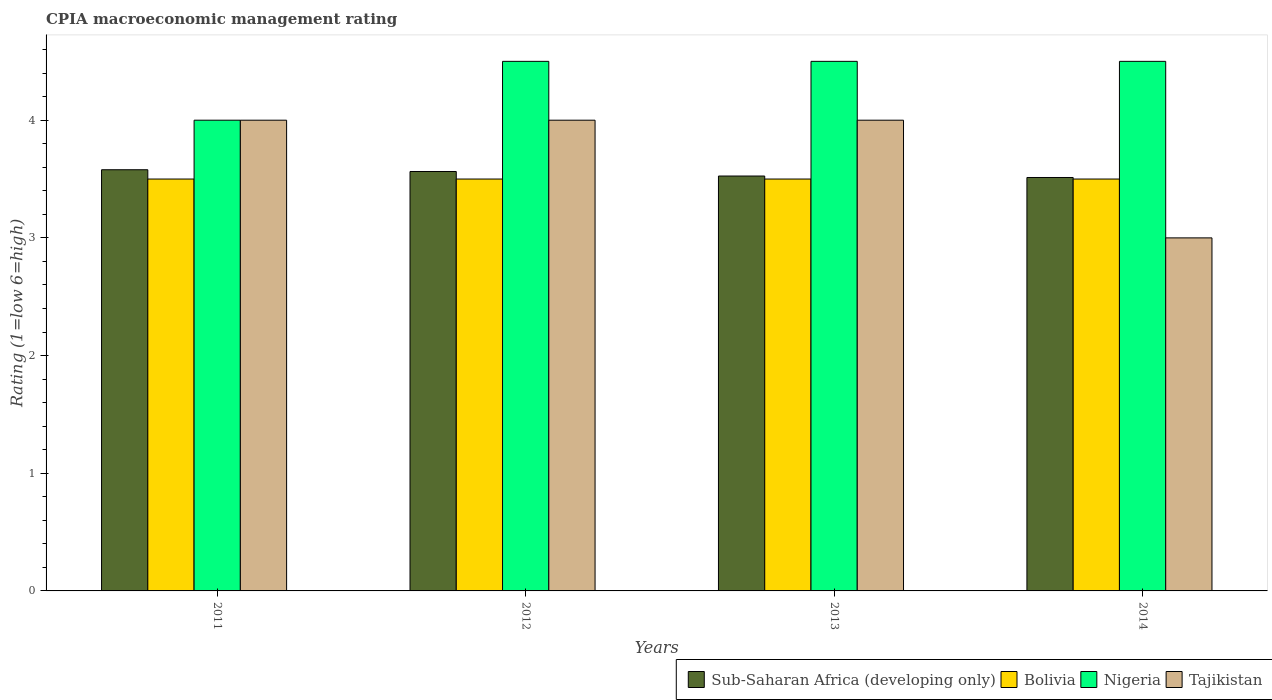How many groups of bars are there?
Your answer should be compact. 4. Are the number of bars per tick equal to the number of legend labels?
Your answer should be compact. Yes. What is the label of the 2nd group of bars from the left?
Offer a very short reply. 2012. In which year was the CPIA rating in Bolivia maximum?
Offer a very short reply. 2011. What is the total CPIA rating in Nigeria in the graph?
Your answer should be very brief. 17.5. What is the average CPIA rating in Sub-Saharan Africa (developing only) per year?
Provide a short and direct response. 3.55. What is the ratio of the CPIA rating in Tajikistan in 2013 to that in 2014?
Keep it short and to the point. 1.33. What is the difference between the highest and the second highest CPIA rating in Nigeria?
Offer a very short reply. 0. Is the sum of the CPIA rating in Sub-Saharan Africa (developing only) in 2012 and 2014 greater than the maximum CPIA rating in Bolivia across all years?
Give a very brief answer. Yes. Is it the case that in every year, the sum of the CPIA rating in Bolivia and CPIA rating in Nigeria is greater than the sum of CPIA rating in Sub-Saharan Africa (developing only) and CPIA rating in Tajikistan?
Provide a succinct answer. No. What does the 1st bar from the left in 2012 represents?
Provide a succinct answer. Sub-Saharan Africa (developing only). What does the 4th bar from the right in 2014 represents?
Your answer should be compact. Sub-Saharan Africa (developing only). Is it the case that in every year, the sum of the CPIA rating in Sub-Saharan Africa (developing only) and CPIA rating in Tajikistan is greater than the CPIA rating in Bolivia?
Offer a terse response. Yes. How many bars are there?
Provide a short and direct response. 16. What is the difference between two consecutive major ticks on the Y-axis?
Provide a short and direct response. 1. Are the values on the major ticks of Y-axis written in scientific E-notation?
Make the answer very short. No. Does the graph contain any zero values?
Your answer should be very brief. No. Does the graph contain grids?
Your answer should be very brief. No. Where does the legend appear in the graph?
Ensure brevity in your answer.  Bottom right. What is the title of the graph?
Ensure brevity in your answer.  CPIA macroeconomic management rating. Does "South Africa" appear as one of the legend labels in the graph?
Give a very brief answer. No. What is the Rating (1=low 6=high) in Sub-Saharan Africa (developing only) in 2011?
Ensure brevity in your answer.  3.58. What is the Rating (1=low 6=high) of Nigeria in 2011?
Offer a very short reply. 4. What is the Rating (1=low 6=high) in Sub-Saharan Africa (developing only) in 2012?
Keep it short and to the point. 3.56. What is the Rating (1=low 6=high) of Nigeria in 2012?
Keep it short and to the point. 4.5. What is the Rating (1=low 6=high) of Tajikistan in 2012?
Offer a very short reply. 4. What is the Rating (1=low 6=high) of Sub-Saharan Africa (developing only) in 2013?
Offer a terse response. 3.53. What is the Rating (1=low 6=high) in Bolivia in 2013?
Keep it short and to the point. 3.5. What is the Rating (1=low 6=high) in Sub-Saharan Africa (developing only) in 2014?
Make the answer very short. 3.51. What is the Rating (1=low 6=high) of Bolivia in 2014?
Provide a succinct answer. 3.5. What is the Rating (1=low 6=high) of Nigeria in 2014?
Ensure brevity in your answer.  4.5. What is the Rating (1=low 6=high) of Tajikistan in 2014?
Ensure brevity in your answer.  3. Across all years, what is the maximum Rating (1=low 6=high) in Sub-Saharan Africa (developing only)?
Give a very brief answer. 3.58. Across all years, what is the maximum Rating (1=low 6=high) of Bolivia?
Your answer should be very brief. 3.5. Across all years, what is the maximum Rating (1=low 6=high) of Nigeria?
Make the answer very short. 4.5. Across all years, what is the minimum Rating (1=low 6=high) of Sub-Saharan Africa (developing only)?
Keep it short and to the point. 3.51. Across all years, what is the minimum Rating (1=low 6=high) in Bolivia?
Your answer should be compact. 3.5. Across all years, what is the minimum Rating (1=low 6=high) of Nigeria?
Your answer should be very brief. 4. What is the total Rating (1=low 6=high) of Sub-Saharan Africa (developing only) in the graph?
Your answer should be compact. 14.18. What is the total Rating (1=low 6=high) of Bolivia in the graph?
Offer a terse response. 14. What is the total Rating (1=low 6=high) of Nigeria in the graph?
Your answer should be compact. 17.5. What is the total Rating (1=low 6=high) in Tajikistan in the graph?
Ensure brevity in your answer.  15. What is the difference between the Rating (1=low 6=high) in Sub-Saharan Africa (developing only) in 2011 and that in 2012?
Offer a very short reply. 0.01. What is the difference between the Rating (1=low 6=high) of Bolivia in 2011 and that in 2012?
Make the answer very short. 0. What is the difference between the Rating (1=low 6=high) of Tajikistan in 2011 and that in 2012?
Keep it short and to the point. 0. What is the difference between the Rating (1=low 6=high) of Sub-Saharan Africa (developing only) in 2011 and that in 2013?
Your answer should be compact. 0.05. What is the difference between the Rating (1=low 6=high) in Bolivia in 2011 and that in 2013?
Give a very brief answer. 0. What is the difference between the Rating (1=low 6=high) of Tajikistan in 2011 and that in 2013?
Offer a terse response. 0. What is the difference between the Rating (1=low 6=high) of Sub-Saharan Africa (developing only) in 2011 and that in 2014?
Provide a short and direct response. 0.07. What is the difference between the Rating (1=low 6=high) of Bolivia in 2011 and that in 2014?
Give a very brief answer. 0. What is the difference between the Rating (1=low 6=high) in Sub-Saharan Africa (developing only) in 2012 and that in 2013?
Keep it short and to the point. 0.04. What is the difference between the Rating (1=low 6=high) of Bolivia in 2012 and that in 2013?
Provide a succinct answer. 0. What is the difference between the Rating (1=low 6=high) of Nigeria in 2012 and that in 2013?
Your response must be concise. 0. What is the difference between the Rating (1=low 6=high) in Tajikistan in 2012 and that in 2013?
Your answer should be very brief. 0. What is the difference between the Rating (1=low 6=high) of Sub-Saharan Africa (developing only) in 2012 and that in 2014?
Offer a very short reply. 0.05. What is the difference between the Rating (1=low 6=high) of Bolivia in 2012 and that in 2014?
Provide a succinct answer. 0. What is the difference between the Rating (1=low 6=high) of Nigeria in 2012 and that in 2014?
Give a very brief answer. 0. What is the difference between the Rating (1=low 6=high) of Tajikistan in 2012 and that in 2014?
Ensure brevity in your answer.  1. What is the difference between the Rating (1=low 6=high) of Sub-Saharan Africa (developing only) in 2013 and that in 2014?
Your answer should be very brief. 0.01. What is the difference between the Rating (1=low 6=high) in Nigeria in 2013 and that in 2014?
Keep it short and to the point. 0. What is the difference between the Rating (1=low 6=high) of Sub-Saharan Africa (developing only) in 2011 and the Rating (1=low 6=high) of Bolivia in 2012?
Keep it short and to the point. 0.08. What is the difference between the Rating (1=low 6=high) of Sub-Saharan Africa (developing only) in 2011 and the Rating (1=low 6=high) of Nigeria in 2012?
Ensure brevity in your answer.  -0.92. What is the difference between the Rating (1=low 6=high) in Sub-Saharan Africa (developing only) in 2011 and the Rating (1=low 6=high) in Tajikistan in 2012?
Offer a very short reply. -0.42. What is the difference between the Rating (1=low 6=high) of Sub-Saharan Africa (developing only) in 2011 and the Rating (1=low 6=high) of Bolivia in 2013?
Make the answer very short. 0.08. What is the difference between the Rating (1=low 6=high) of Sub-Saharan Africa (developing only) in 2011 and the Rating (1=low 6=high) of Nigeria in 2013?
Your answer should be very brief. -0.92. What is the difference between the Rating (1=low 6=high) in Sub-Saharan Africa (developing only) in 2011 and the Rating (1=low 6=high) in Tajikistan in 2013?
Provide a succinct answer. -0.42. What is the difference between the Rating (1=low 6=high) in Bolivia in 2011 and the Rating (1=low 6=high) in Tajikistan in 2013?
Your answer should be compact. -0.5. What is the difference between the Rating (1=low 6=high) in Nigeria in 2011 and the Rating (1=low 6=high) in Tajikistan in 2013?
Your answer should be compact. 0. What is the difference between the Rating (1=low 6=high) in Sub-Saharan Africa (developing only) in 2011 and the Rating (1=low 6=high) in Bolivia in 2014?
Offer a terse response. 0.08. What is the difference between the Rating (1=low 6=high) of Sub-Saharan Africa (developing only) in 2011 and the Rating (1=low 6=high) of Nigeria in 2014?
Provide a succinct answer. -0.92. What is the difference between the Rating (1=low 6=high) in Sub-Saharan Africa (developing only) in 2011 and the Rating (1=low 6=high) in Tajikistan in 2014?
Offer a terse response. 0.58. What is the difference between the Rating (1=low 6=high) of Bolivia in 2011 and the Rating (1=low 6=high) of Tajikistan in 2014?
Your response must be concise. 0.5. What is the difference between the Rating (1=low 6=high) of Nigeria in 2011 and the Rating (1=low 6=high) of Tajikistan in 2014?
Your answer should be very brief. 1. What is the difference between the Rating (1=low 6=high) of Sub-Saharan Africa (developing only) in 2012 and the Rating (1=low 6=high) of Bolivia in 2013?
Give a very brief answer. 0.06. What is the difference between the Rating (1=low 6=high) of Sub-Saharan Africa (developing only) in 2012 and the Rating (1=low 6=high) of Nigeria in 2013?
Give a very brief answer. -0.94. What is the difference between the Rating (1=low 6=high) of Sub-Saharan Africa (developing only) in 2012 and the Rating (1=low 6=high) of Tajikistan in 2013?
Keep it short and to the point. -0.44. What is the difference between the Rating (1=low 6=high) in Nigeria in 2012 and the Rating (1=low 6=high) in Tajikistan in 2013?
Your answer should be compact. 0.5. What is the difference between the Rating (1=low 6=high) of Sub-Saharan Africa (developing only) in 2012 and the Rating (1=low 6=high) of Bolivia in 2014?
Your answer should be compact. 0.06. What is the difference between the Rating (1=low 6=high) of Sub-Saharan Africa (developing only) in 2012 and the Rating (1=low 6=high) of Nigeria in 2014?
Keep it short and to the point. -0.94. What is the difference between the Rating (1=low 6=high) in Sub-Saharan Africa (developing only) in 2012 and the Rating (1=low 6=high) in Tajikistan in 2014?
Provide a succinct answer. 0.56. What is the difference between the Rating (1=low 6=high) of Bolivia in 2012 and the Rating (1=low 6=high) of Tajikistan in 2014?
Make the answer very short. 0.5. What is the difference between the Rating (1=low 6=high) of Nigeria in 2012 and the Rating (1=low 6=high) of Tajikistan in 2014?
Your answer should be very brief. 1.5. What is the difference between the Rating (1=low 6=high) of Sub-Saharan Africa (developing only) in 2013 and the Rating (1=low 6=high) of Bolivia in 2014?
Provide a succinct answer. 0.03. What is the difference between the Rating (1=low 6=high) in Sub-Saharan Africa (developing only) in 2013 and the Rating (1=low 6=high) in Nigeria in 2014?
Provide a short and direct response. -0.97. What is the difference between the Rating (1=low 6=high) of Sub-Saharan Africa (developing only) in 2013 and the Rating (1=low 6=high) of Tajikistan in 2014?
Your response must be concise. 0.53. What is the difference between the Rating (1=low 6=high) in Nigeria in 2013 and the Rating (1=low 6=high) in Tajikistan in 2014?
Your answer should be very brief. 1.5. What is the average Rating (1=low 6=high) of Sub-Saharan Africa (developing only) per year?
Offer a terse response. 3.55. What is the average Rating (1=low 6=high) in Bolivia per year?
Your answer should be compact. 3.5. What is the average Rating (1=low 6=high) in Nigeria per year?
Make the answer very short. 4.38. What is the average Rating (1=low 6=high) in Tajikistan per year?
Your answer should be compact. 3.75. In the year 2011, what is the difference between the Rating (1=low 6=high) in Sub-Saharan Africa (developing only) and Rating (1=low 6=high) in Bolivia?
Ensure brevity in your answer.  0.08. In the year 2011, what is the difference between the Rating (1=low 6=high) in Sub-Saharan Africa (developing only) and Rating (1=low 6=high) in Nigeria?
Your response must be concise. -0.42. In the year 2011, what is the difference between the Rating (1=low 6=high) of Sub-Saharan Africa (developing only) and Rating (1=low 6=high) of Tajikistan?
Provide a short and direct response. -0.42. In the year 2011, what is the difference between the Rating (1=low 6=high) of Bolivia and Rating (1=low 6=high) of Nigeria?
Your response must be concise. -0.5. In the year 2011, what is the difference between the Rating (1=low 6=high) in Nigeria and Rating (1=low 6=high) in Tajikistan?
Your response must be concise. 0. In the year 2012, what is the difference between the Rating (1=low 6=high) of Sub-Saharan Africa (developing only) and Rating (1=low 6=high) of Bolivia?
Your answer should be very brief. 0.06. In the year 2012, what is the difference between the Rating (1=low 6=high) of Sub-Saharan Africa (developing only) and Rating (1=low 6=high) of Nigeria?
Provide a short and direct response. -0.94. In the year 2012, what is the difference between the Rating (1=low 6=high) of Sub-Saharan Africa (developing only) and Rating (1=low 6=high) of Tajikistan?
Your response must be concise. -0.44. In the year 2012, what is the difference between the Rating (1=low 6=high) in Bolivia and Rating (1=low 6=high) in Tajikistan?
Your answer should be very brief. -0.5. In the year 2013, what is the difference between the Rating (1=low 6=high) in Sub-Saharan Africa (developing only) and Rating (1=low 6=high) in Bolivia?
Keep it short and to the point. 0.03. In the year 2013, what is the difference between the Rating (1=low 6=high) in Sub-Saharan Africa (developing only) and Rating (1=low 6=high) in Nigeria?
Your answer should be very brief. -0.97. In the year 2013, what is the difference between the Rating (1=low 6=high) of Sub-Saharan Africa (developing only) and Rating (1=low 6=high) of Tajikistan?
Make the answer very short. -0.47. In the year 2013, what is the difference between the Rating (1=low 6=high) of Bolivia and Rating (1=low 6=high) of Nigeria?
Your answer should be very brief. -1. In the year 2013, what is the difference between the Rating (1=low 6=high) in Bolivia and Rating (1=low 6=high) in Tajikistan?
Your response must be concise. -0.5. In the year 2013, what is the difference between the Rating (1=low 6=high) in Nigeria and Rating (1=low 6=high) in Tajikistan?
Your response must be concise. 0.5. In the year 2014, what is the difference between the Rating (1=low 6=high) in Sub-Saharan Africa (developing only) and Rating (1=low 6=high) in Bolivia?
Ensure brevity in your answer.  0.01. In the year 2014, what is the difference between the Rating (1=low 6=high) in Sub-Saharan Africa (developing only) and Rating (1=low 6=high) in Nigeria?
Give a very brief answer. -0.99. In the year 2014, what is the difference between the Rating (1=low 6=high) of Sub-Saharan Africa (developing only) and Rating (1=low 6=high) of Tajikistan?
Offer a terse response. 0.51. What is the ratio of the Rating (1=low 6=high) in Sub-Saharan Africa (developing only) in 2011 to that in 2012?
Ensure brevity in your answer.  1. What is the ratio of the Rating (1=low 6=high) of Sub-Saharan Africa (developing only) in 2011 to that in 2013?
Your answer should be compact. 1.02. What is the ratio of the Rating (1=low 6=high) of Bolivia in 2011 to that in 2013?
Your answer should be very brief. 1. What is the ratio of the Rating (1=low 6=high) of Nigeria in 2011 to that in 2013?
Offer a terse response. 0.89. What is the ratio of the Rating (1=low 6=high) in Tajikistan in 2011 to that in 2013?
Make the answer very short. 1. What is the ratio of the Rating (1=low 6=high) of Sub-Saharan Africa (developing only) in 2011 to that in 2014?
Ensure brevity in your answer.  1.02. What is the ratio of the Rating (1=low 6=high) in Bolivia in 2011 to that in 2014?
Provide a succinct answer. 1. What is the ratio of the Rating (1=low 6=high) of Tajikistan in 2011 to that in 2014?
Your answer should be very brief. 1.33. What is the ratio of the Rating (1=low 6=high) in Sub-Saharan Africa (developing only) in 2012 to that in 2013?
Your response must be concise. 1.01. What is the ratio of the Rating (1=low 6=high) in Bolivia in 2012 to that in 2013?
Make the answer very short. 1. What is the ratio of the Rating (1=low 6=high) in Sub-Saharan Africa (developing only) in 2012 to that in 2014?
Make the answer very short. 1.01. What is the ratio of the Rating (1=low 6=high) of Nigeria in 2012 to that in 2014?
Your response must be concise. 1. What is the ratio of the Rating (1=low 6=high) in Sub-Saharan Africa (developing only) in 2013 to that in 2014?
Make the answer very short. 1. What is the ratio of the Rating (1=low 6=high) in Tajikistan in 2013 to that in 2014?
Give a very brief answer. 1.33. What is the difference between the highest and the second highest Rating (1=low 6=high) of Sub-Saharan Africa (developing only)?
Your response must be concise. 0.01. What is the difference between the highest and the second highest Rating (1=low 6=high) in Bolivia?
Provide a short and direct response. 0. What is the difference between the highest and the lowest Rating (1=low 6=high) of Sub-Saharan Africa (developing only)?
Ensure brevity in your answer.  0.07. What is the difference between the highest and the lowest Rating (1=low 6=high) in Tajikistan?
Your answer should be compact. 1. 